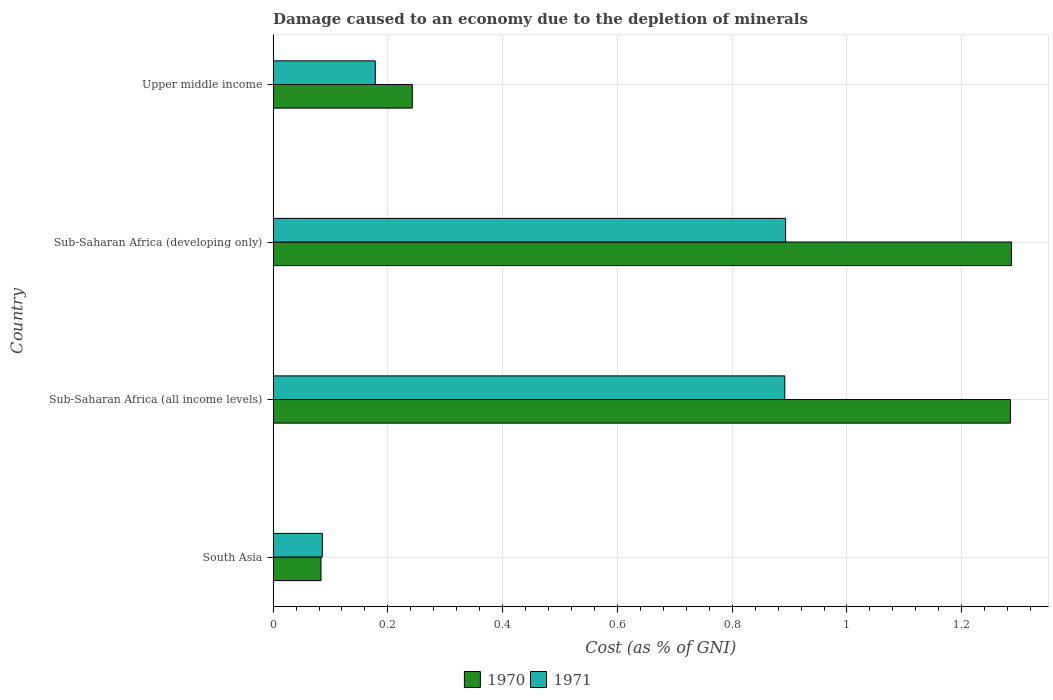Are the number of bars per tick equal to the number of legend labels?
Ensure brevity in your answer.  Yes. Are the number of bars on each tick of the Y-axis equal?
Provide a short and direct response. Yes. How many bars are there on the 2nd tick from the top?
Keep it short and to the point. 2. What is the label of the 2nd group of bars from the top?
Your response must be concise. Sub-Saharan Africa (developing only). In how many cases, is the number of bars for a given country not equal to the number of legend labels?
Provide a short and direct response. 0. What is the cost of damage caused due to the depletion of minerals in 1971 in Sub-Saharan Africa (all income levels)?
Offer a terse response. 0.89. Across all countries, what is the maximum cost of damage caused due to the depletion of minerals in 1971?
Your answer should be compact. 0.89. Across all countries, what is the minimum cost of damage caused due to the depletion of minerals in 1970?
Offer a terse response. 0.08. In which country was the cost of damage caused due to the depletion of minerals in 1971 maximum?
Your answer should be compact. Sub-Saharan Africa (developing only). What is the total cost of damage caused due to the depletion of minerals in 1971 in the graph?
Provide a short and direct response. 2.05. What is the difference between the cost of damage caused due to the depletion of minerals in 1970 in South Asia and that in Upper middle income?
Provide a succinct answer. -0.16. What is the difference between the cost of damage caused due to the depletion of minerals in 1971 in Sub-Saharan Africa (all income levels) and the cost of damage caused due to the depletion of minerals in 1970 in Sub-Saharan Africa (developing only)?
Keep it short and to the point. -0.4. What is the average cost of damage caused due to the depletion of minerals in 1971 per country?
Make the answer very short. 0.51. What is the difference between the cost of damage caused due to the depletion of minerals in 1970 and cost of damage caused due to the depletion of minerals in 1971 in South Asia?
Your response must be concise. -0. In how many countries, is the cost of damage caused due to the depletion of minerals in 1971 greater than 0.52 %?
Your response must be concise. 2. What is the ratio of the cost of damage caused due to the depletion of minerals in 1970 in South Asia to that in Sub-Saharan Africa (all income levels)?
Offer a very short reply. 0.06. Is the cost of damage caused due to the depletion of minerals in 1970 in South Asia less than that in Sub-Saharan Africa (all income levels)?
Ensure brevity in your answer.  Yes. What is the difference between the highest and the second highest cost of damage caused due to the depletion of minerals in 1971?
Offer a very short reply. 0. What is the difference between the highest and the lowest cost of damage caused due to the depletion of minerals in 1970?
Make the answer very short. 1.2. In how many countries, is the cost of damage caused due to the depletion of minerals in 1971 greater than the average cost of damage caused due to the depletion of minerals in 1971 taken over all countries?
Ensure brevity in your answer.  2. Is the sum of the cost of damage caused due to the depletion of minerals in 1970 in South Asia and Sub-Saharan Africa (all income levels) greater than the maximum cost of damage caused due to the depletion of minerals in 1971 across all countries?
Provide a short and direct response. Yes. How many countries are there in the graph?
Provide a succinct answer. 4. Are the values on the major ticks of X-axis written in scientific E-notation?
Provide a short and direct response. No. Where does the legend appear in the graph?
Keep it short and to the point. Bottom center. What is the title of the graph?
Your response must be concise. Damage caused to an economy due to the depletion of minerals. Does "1961" appear as one of the legend labels in the graph?
Ensure brevity in your answer.  No. What is the label or title of the X-axis?
Offer a terse response. Cost (as % of GNI). What is the Cost (as % of GNI) in 1970 in South Asia?
Give a very brief answer. 0.08. What is the Cost (as % of GNI) of 1971 in South Asia?
Provide a short and direct response. 0.09. What is the Cost (as % of GNI) of 1970 in Sub-Saharan Africa (all income levels)?
Your answer should be compact. 1.28. What is the Cost (as % of GNI) in 1971 in Sub-Saharan Africa (all income levels)?
Ensure brevity in your answer.  0.89. What is the Cost (as % of GNI) of 1970 in Sub-Saharan Africa (developing only)?
Your answer should be very brief. 1.29. What is the Cost (as % of GNI) in 1971 in Sub-Saharan Africa (developing only)?
Keep it short and to the point. 0.89. What is the Cost (as % of GNI) of 1970 in Upper middle income?
Your answer should be very brief. 0.24. What is the Cost (as % of GNI) in 1971 in Upper middle income?
Your response must be concise. 0.18. Across all countries, what is the maximum Cost (as % of GNI) in 1970?
Your answer should be compact. 1.29. Across all countries, what is the maximum Cost (as % of GNI) of 1971?
Keep it short and to the point. 0.89. Across all countries, what is the minimum Cost (as % of GNI) in 1970?
Ensure brevity in your answer.  0.08. Across all countries, what is the minimum Cost (as % of GNI) of 1971?
Ensure brevity in your answer.  0.09. What is the total Cost (as % of GNI) in 1970 in the graph?
Provide a short and direct response. 2.9. What is the total Cost (as % of GNI) of 1971 in the graph?
Your answer should be compact. 2.05. What is the difference between the Cost (as % of GNI) in 1970 in South Asia and that in Sub-Saharan Africa (all income levels)?
Provide a succinct answer. -1.2. What is the difference between the Cost (as % of GNI) of 1971 in South Asia and that in Sub-Saharan Africa (all income levels)?
Provide a succinct answer. -0.81. What is the difference between the Cost (as % of GNI) of 1970 in South Asia and that in Sub-Saharan Africa (developing only)?
Ensure brevity in your answer.  -1.2. What is the difference between the Cost (as % of GNI) of 1971 in South Asia and that in Sub-Saharan Africa (developing only)?
Your answer should be compact. -0.81. What is the difference between the Cost (as % of GNI) of 1970 in South Asia and that in Upper middle income?
Your answer should be compact. -0.16. What is the difference between the Cost (as % of GNI) of 1971 in South Asia and that in Upper middle income?
Provide a succinct answer. -0.09. What is the difference between the Cost (as % of GNI) in 1970 in Sub-Saharan Africa (all income levels) and that in Sub-Saharan Africa (developing only)?
Your answer should be compact. -0. What is the difference between the Cost (as % of GNI) in 1971 in Sub-Saharan Africa (all income levels) and that in Sub-Saharan Africa (developing only)?
Provide a short and direct response. -0. What is the difference between the Cost (as % of GNI) in 1970 in Sub-Saharan Africa (all income levels) and that in Upper middle income?
Provide a short and direct response. 1.04. What is the difference between the Cost (as % of GNI) of 1971 in Sub-Saharan Africa (all income levels) and that in Upper middle income?
Offer a terse response. 0.71. What is the difference between the Cost (as % of GNI) of 1970 in Sub-Saharan Africa (developing only) and that in Upper middle income?
Give a very brief answer. 1.04. What is the difference between the Cost (as % of GNI) of 1971 in Sub-Saharan Africa (developing only) and that in Upper middle income?
Offer a very short reply. 0.71. What is the difference between the Cost (as % of GNI) in 1970 in South Asia and the Cost (as % of GNI) in 1971 in Sub-Saharan Africa (all income levels)?
Provide a short and direct response. -0.81. What is the difference between the Cost (as % of GNI) of 1970 in South Asia and the Cost (as % of GNI) of 1971 in Sub-Saharan Africa (developing only)?
Offer a terse response. -0.81. What is the difference between the Cost (as % of GNI) in 1970 in South Asia and the Cost (as % of GNI) in 1971 in Upper middle income?
Your answer should be compact. -0.09. What is the difference between the Cost (as % of GNI) in 1970 in Sub-Saharan Africa (all income levels) and the Cost (as % of GNI) in 1971 in Sub-Saharan Africa (developing only)?
Provide a succinct answer. 0.39. What is the difference between the Cost (as % of GNI) in 1970 in Sub-Saharan Africa (all income levels) and the Cost (as % of GNI) in 1971 in Upper middle income?
Provide a short and direct response. 1.11. What is the difference between the Cost (as % of GNI) of 1970 in Sub-Saharan Africa (developing only) and the Cost (as % of GNI) of 1971 in Upper middle income?
Offer a very short reply. 1.11. What is the average Cost (as % of GNI) of 1970 per country?
Ensure brevity in your answer.  0.72. What is the average Cost (as % of GNI) of 1971 per country?
Give a very brief answer. 0.51. What is the difference between the Cost (as % of GNI) in 1970 and Cost (as % of GNI) in 1971 in South Asia?
Offer a very short reply. -0. What is the difference between the Cost (as % of GNI) in 1970 and Cost (as % of GNI) in 1971 in Sub-Saharan Africa (all income levels)?
Provide a short and direct response. 0.39. What is the difference between the Cost (as % of GNI) of 1970 and Cost (as % of GNI) of 1971 in Sub-Saharan Africa (developing only)?
Ensure brevity in your answer.  0.39. What is the difference between the Cost (as % of GNI) in 1970 and Cost (as % of GNI) in 1971 in Upper middle income?
Give a very brief answer. 0.06. What is the ratio of the Cost (as % of GNI) in 1970 in South Asia to that in Sub-Saharan Africa (all income levels)?
Provide a succinct answer. 0.06. What is the ratio of the Cost (as % of GNI) of 1971 in South Asia to that in Sub-Saharan Africa (all income levels)?
Keep it short and to the point. 0.1. What is the ratio of the Cost (as % of GNI) in 1970 in South Asia to that in Sub-Saharan Africa (developing only)?
Offer a very short reply. 0.06. What is the ratio of the Cost (as % of GNI) in 1971 in South Asia to that in Sub-Saharan Africa (developing only)?
Your answer should be very brief. 0.1. What is the ratio of the Cost (as % of GNI) in 1970 in South Asia to that in Upper middle income?
Keep it short and to the point. 0.34. What is the ratio of the Cost (as % of GNI) of 1971 in South Asia to that in Upper middle income?
Provide a short and direct response. 0.48. What is the ratio of the Cost (as % of GNI) in 1970 in Sub-Saharan Africa (all income levels) to that in Sub-Saharan Africa (developing only)?
Provide a succinct answer. 1. What is the ratio of the Cost (as % of GNI) of 1970 in Sub-Saharan Africa (all income levels) to that in Upper middle income?
Provide a short and direct response. 5.3. What is the ratio of the Cost (as % of GNI) of 1971 in Sub-Saharan Africa (all income levels) to that in Upper middle income?
Offer a very short reply. 5.01. What is the ratio of the Cost (as % of GNI) of 1970 in Sub-Saharan Africa (developing only) to that in Upper middle income?
Your answer should be very brief. 5.31. What is the ratio of the Cost (as % of GNI) of 1971 in Sub-Saharan Africa (developing only) to that in Upper middle income?
Ensure brevity in your answer.  5.02. What is the difference between the highest and the second highest Cost (as % of GNI) in 1970?
Your answer should be very brief. 0. What is the difference between the highest and the second highest Cost (as % of GNI) in 1971?
Offer a very short reply. 0. What is the difference between the highest and the lowest Cost (as % of GNI) of 1970?
Provide a succinct answer. 1.2. What is the difference between the highest and the lowest Cost (as % of GNI) of 1971?
Ensure brevity in your answer.  0.81. 